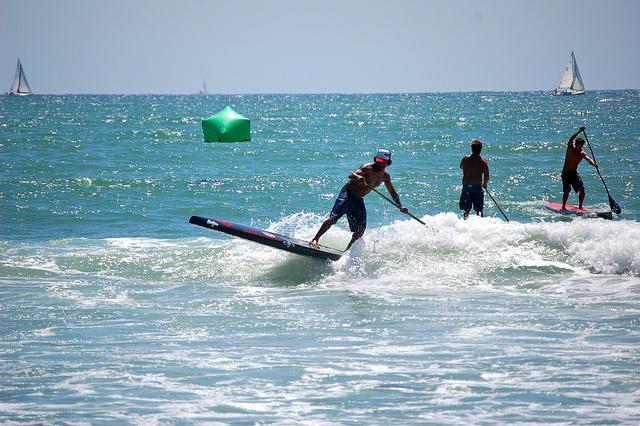How many sailboats are shown?
Give a very brief answer. 2. How many surfboards are in the photo?
Give a very brief answer. 1. 